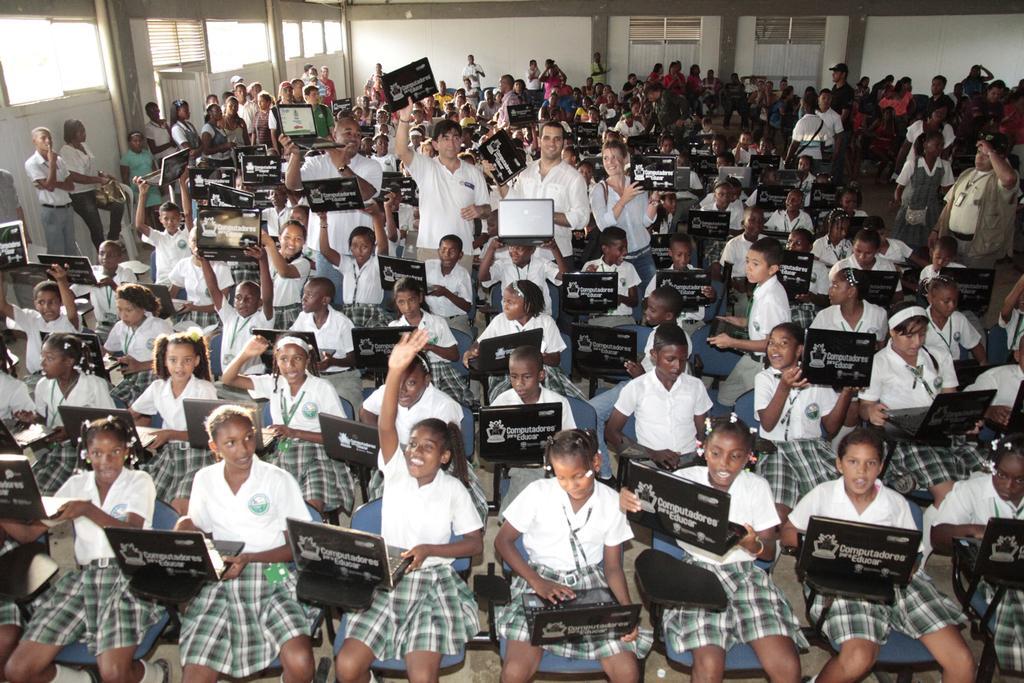Can you describe this image briefly? In this picture, we see the girls and the boys are sitting on the chairs. They are holding the laptops in their hands and they are operating the laptops. In the middle, we see three people are standing and they are holding the laptops in their hands. In the background, we see the people are standing. Behind them, we see a white wall and the windows. This picture might be clicked in the classroom. 